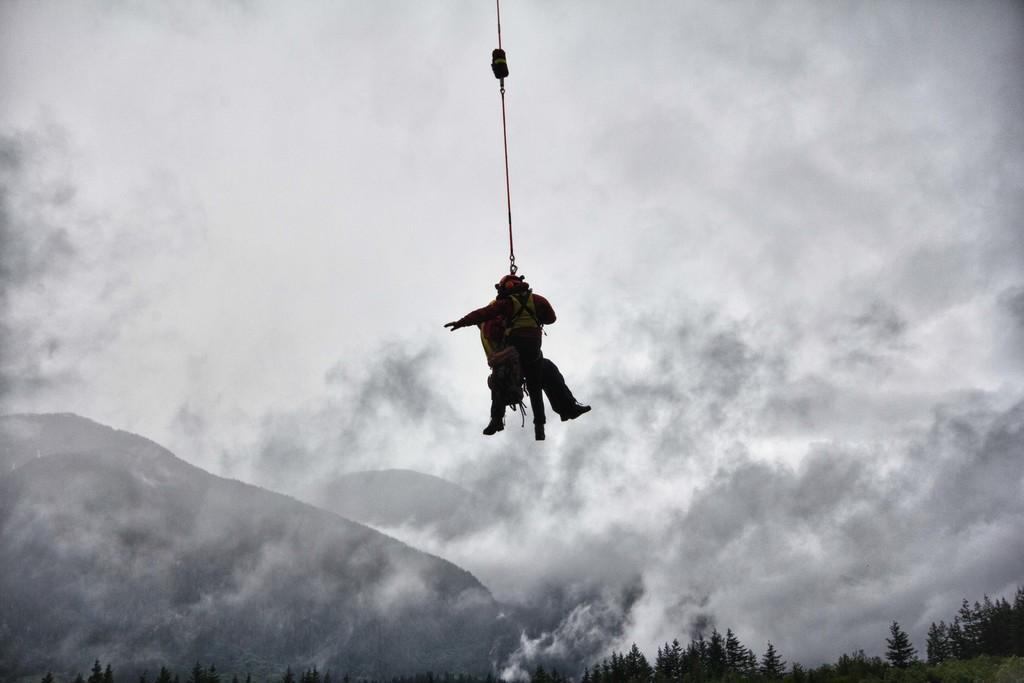In one or two sentences, can you explain what this image depicts? In the picture I can see two persons in the air and there is a rope tightened to them and there are trees in the right bottom corner and the background is cloudy. 